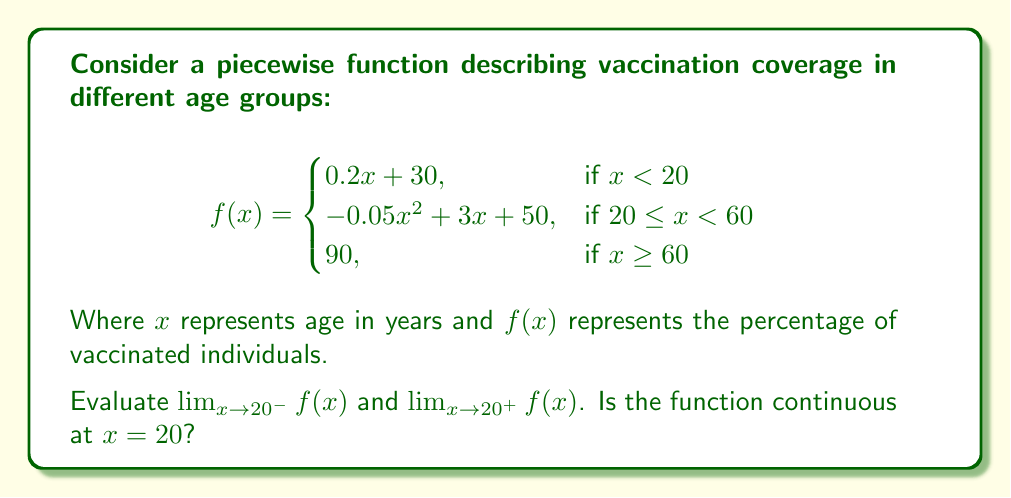Help me with this question. To evaluate the limits and determine continuity, we'll follow these steps:

1. Evaluate $\lim_{x \to 20^-} f(x)$:
   This limit approaches 20 from the left, so we use the first piece of the function.
   $$\lim_{x \to 20^-} f(x) = \lim_{x \to 20^-} (0.2x + 30) = 0.2(20) + 30 = 34$$

2. Evaluate $\lim_{x \to 20^+} f(x)$:
   This limit approaches 20 from the right, so we use the second piece of the function.
   $$\lim_{x \to 20^+} f(x) = \lim_{x \to 20^+} (-0.05x^2 + 3x + 50)$$
   $$= -0.05(20)^2 + 3(20) + 50 = -20 + 60 + 50 = 90$$

3. Check for continuity at $x = 20$:
   For the function to be continuous at $x = 20$, three conditions must be met:
   a) $\lim_{x \to 20^-} f(x)$ exists
   b) $\lim_{x \to 20^+} f(x)$ exists
   c) $\lim_{x \to 20^-} f(x) = \lim_{x \to 20^+} f(x) = f(20)$

   We've shown that both one-sided limits exist, but they are not equal:
   $\lim_{x \to 20^-} f(x) = 34$ and $\lim_{x \to 20^+} f(x) = 90$

   Therefore, the function is not continuous at $x = 20$.
Answer: $\lim_{x \to 20^-} f(x) = 34$, $\lim_{x \to 20^+} f(x) = 90$. Not continuous at $x = 20$. 